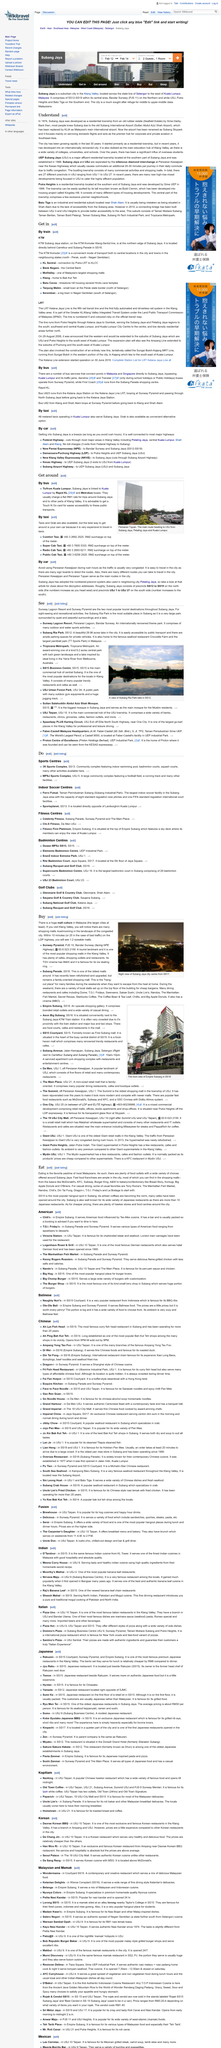Specify some key components in this picture. Persiaran Kewajipan and Persiaran Tujuan are the main routes in the city, serving as the primary means of transportation for residents and visitors alike. According to the article "Understand," Subang Jaya was developed in the year 1974. In Subang, SS15 is the most popular hangout spot. It is not advisable to use a car as a mode of transportation on Persiaran Kewajipan during rush hours due to the congested traffic conditions that may lead to delays, frustration, and inconvenience. The name of the new airport has been changed to Subang Skypark, as announced. 